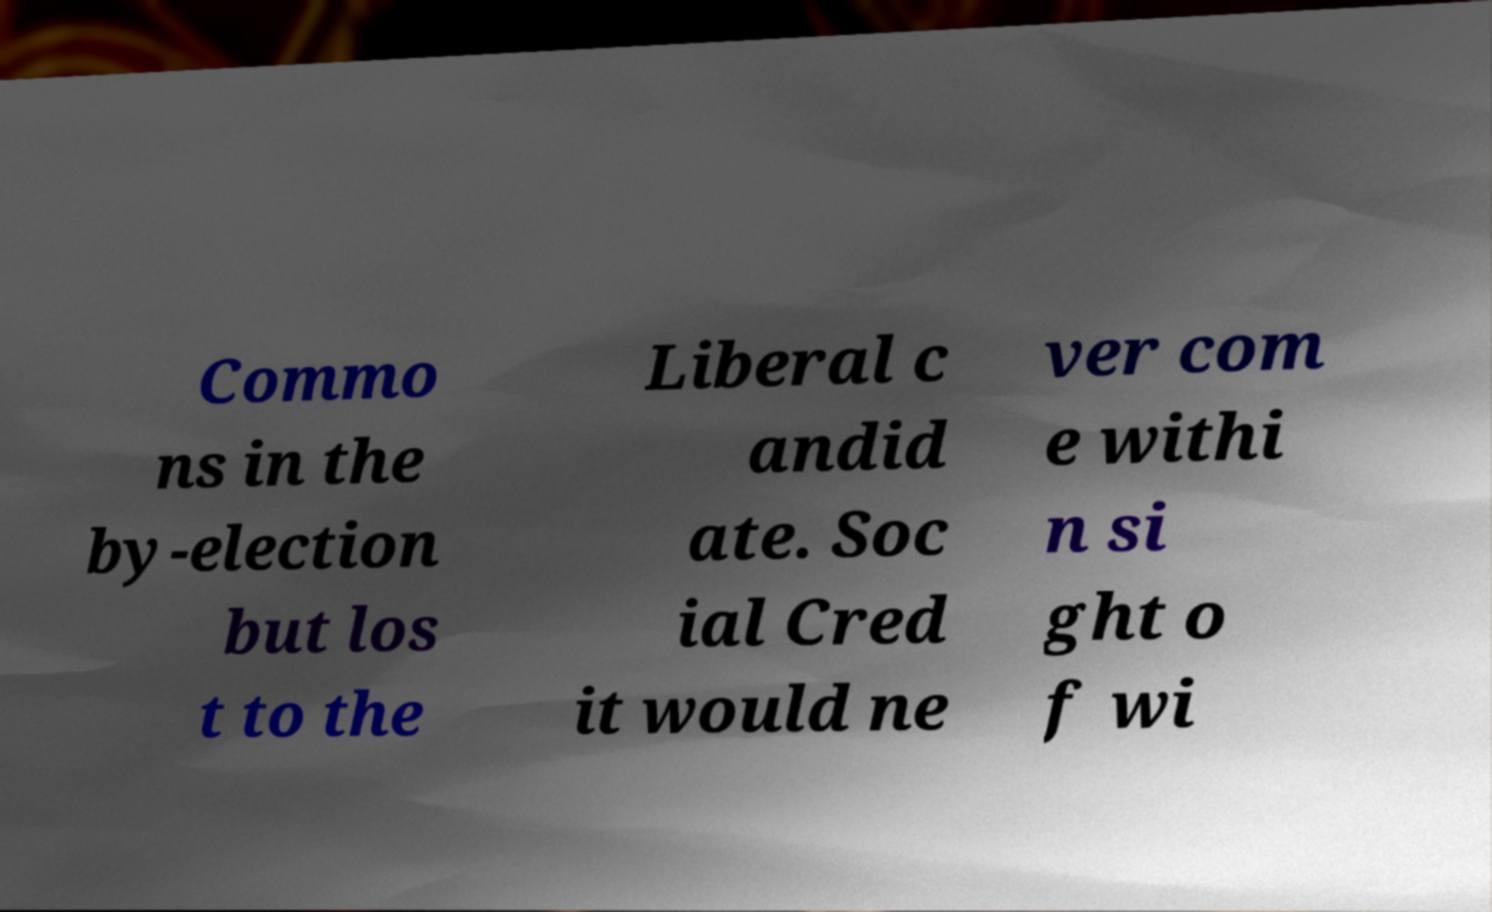Could you assist in decoding the text presented in this image and type it out clearly? Commo ns in the by-election but los t to the Liberal c andid ate. Soc ial Cred it would ne ver com e withi n si ght o f wi 